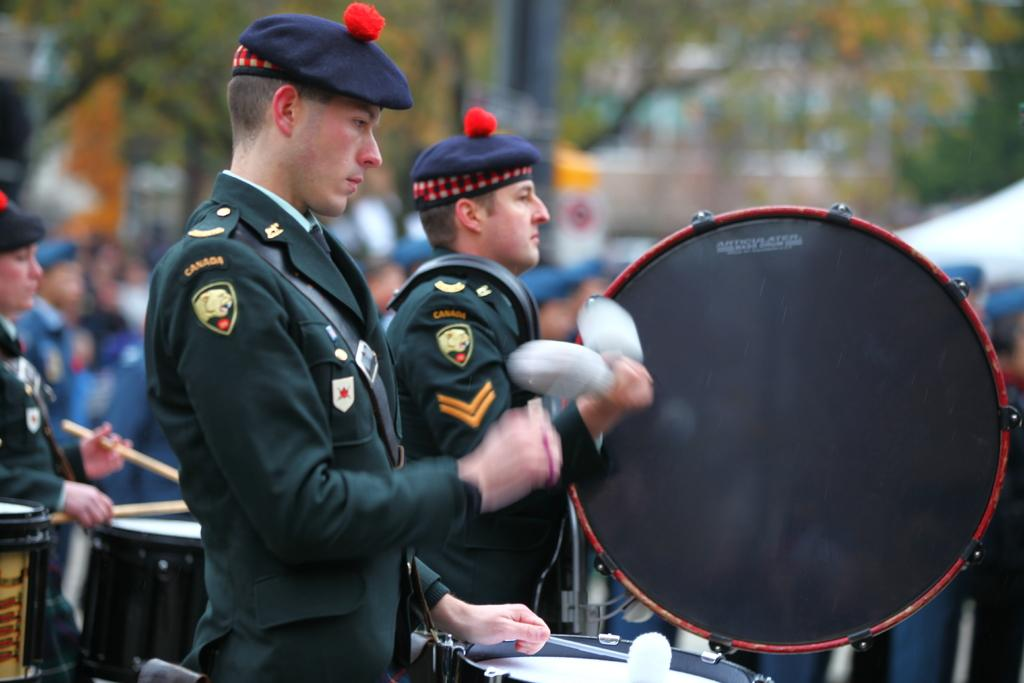What are the people in the foreground of the image doing? The people in the foreground of the image are playing drums. What can be seen in the background of the image? There are trees in the background of the image. What direction are the people driving in the image? There are no vehicles or driving present in the image; the people are playing drums. 